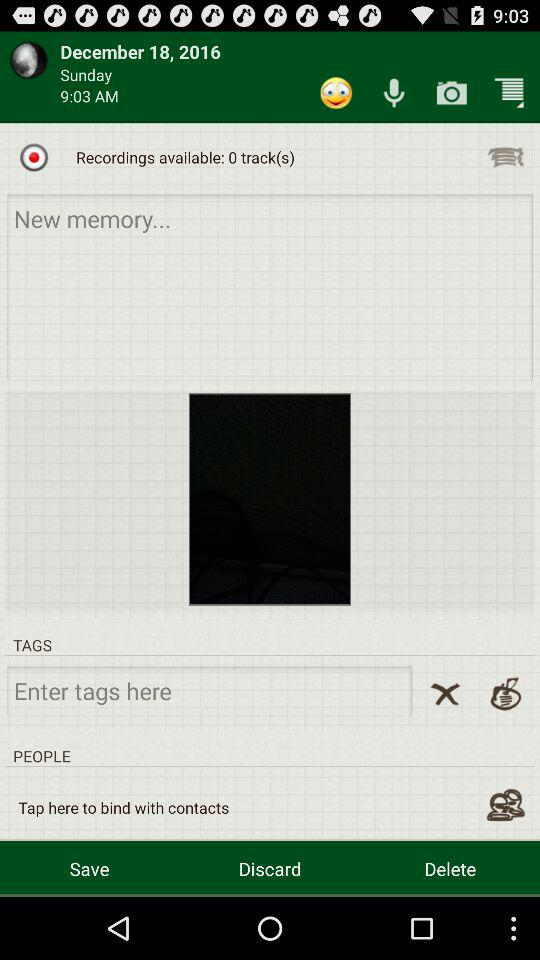What is the time of recording? The time of the recording is 9:03 AM. 